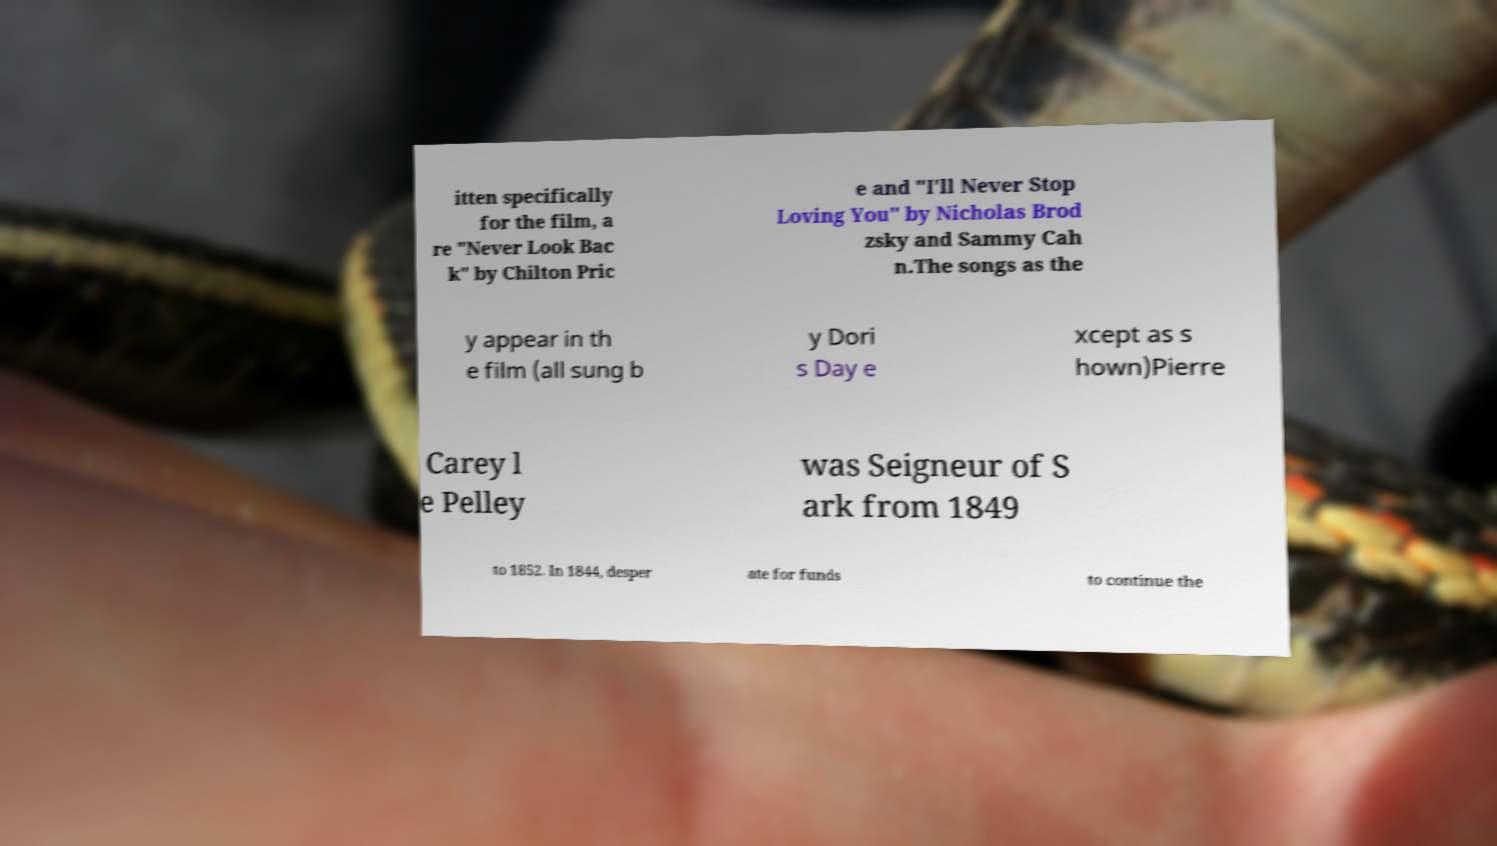Can you read and provide the text displayed in the image?This photo seems to have some interesting text. Can you extract and type it out for me? itten specifically for the film, a re "Never Look Bac k" by Chilton Pric e and "I'll Never Stop Loving You" by Nicholas Brod zsky and Sammy Cah n.The songs as the y appear in th e film (all sung b y Dori s Day e xcept as s hown)Pierre Carey l e Pelley was Seigneur of S ark from 1849 to 1852. In 1844, desper ate for funds to continue the 